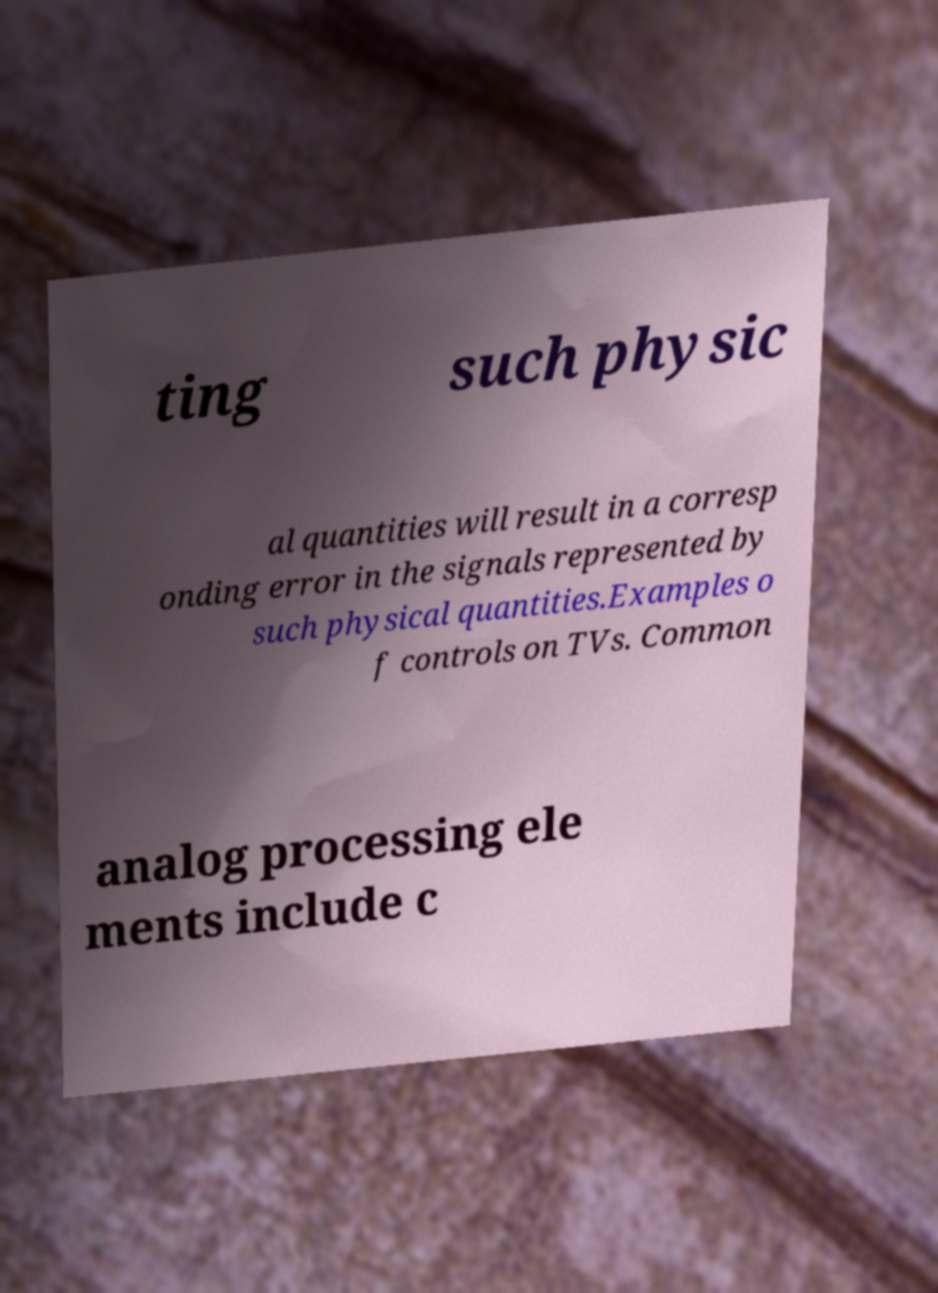There's text embedded in this image that I need extracted. Can you transcribe it verbatim? ting such physic al quantities will result in a corresp onding error in the signals represented by such physical quantities.Examples o f controls on TVs. Common analog processing ele ments include c 